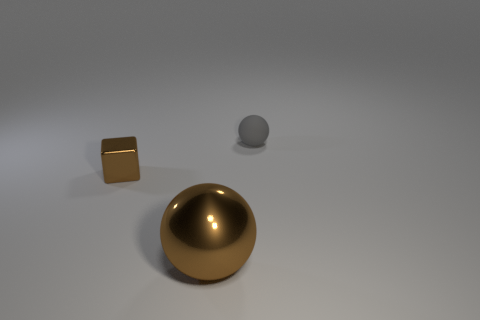Is the number of tiny brown cubes that are in front of the gray rubber thing greater than the number of small red matte cylinders?
Ensure brevity in your answer.  Yes. What number of other objects are the same size as the matte thing?
Your answer should be compact. 1. How many large shiny objects are on the left side of the large ball?
Your answer should be very brief. 0. Are there the same number of tiny gray matte balls that are to the left of the big brown metal ball and rubber objects that are in front of the tiny metallic object?
Make the answer very short. Yes. What size is the gray rubber object that is the same shape as the big shiny thing?
Provide a short and direct response. Small. There is a thing to the left of the big brown metal sphere; what shape is it?
Provide a succinct answer. Cube. Does the tiny thing that is on the right side of the large brown thing have the same material as the object in front of the small brown thing?
Keep it short and to the point. No. The rubber thing has what shape?
Give a very brief answer. Sphere. Are there an equal number of brown metallic balls that are left of the big ball and brown blocks?
Your answer should be compact. No. The ball that is the same color as the shiny block is what size?
Provide a short and direct response. Large. 